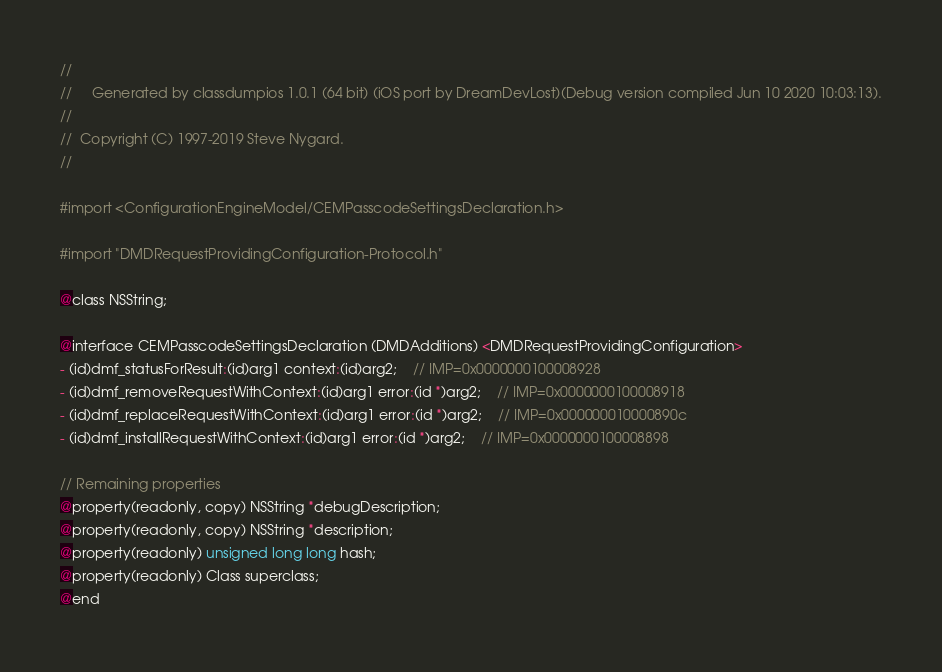<code> <loc_0><loc_0><loc_500><loc_500><_C_>//
//     Generated by classdumpios 1.0.1 (64 bit) (iOS port by DreamDevLost)(Debug version compiled Jun 10 2020 10:03:13).
//
//  Copyright (C) 1997-2019 Steve Nygard.
//

#import <ConfigurationEngineModel/CEMPasscodeSettingsDeclaration.h>

#import "DMDRequestProvidingConfiguration-Protocol.h"

@class NSString;

@interface CEMPasscodeSettingsDeclaration (DMDAdditions) <DMDRequestProvidingConfiguration>
- (id)dmf_statusForResult:(id)arg1 context:(id)arg2;	// IMP=0x0000000100008928
- (id)dmf_removeRequestWithContext:(id)arg1 error:(id *)arg2;	// IMP=0x0000000100008918
- (id)dmf_replaceRequestWithContext:(id)arg1 error:(id *)arg2;	// IMP=0x000000010000890c
- (id)dmf_installRequestWithContext:(id)arg1 error:(id *)arg2;	// IMP=0x0000000100008898

// Remaining properties
@property(readonly, copy) NSString *debugDescription;
@property(readonly, copy) NSString *description;
@property(readonly) unsigned long long hash;
@property(readonly) Class superclass;
@end

</code> 